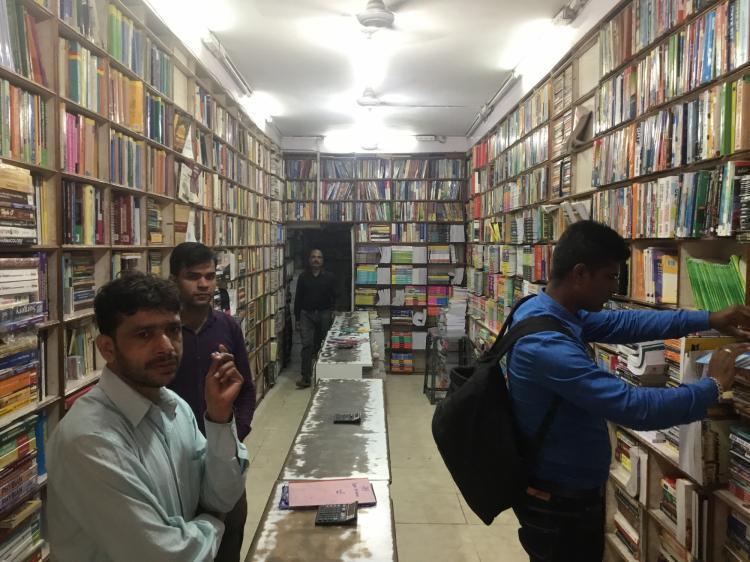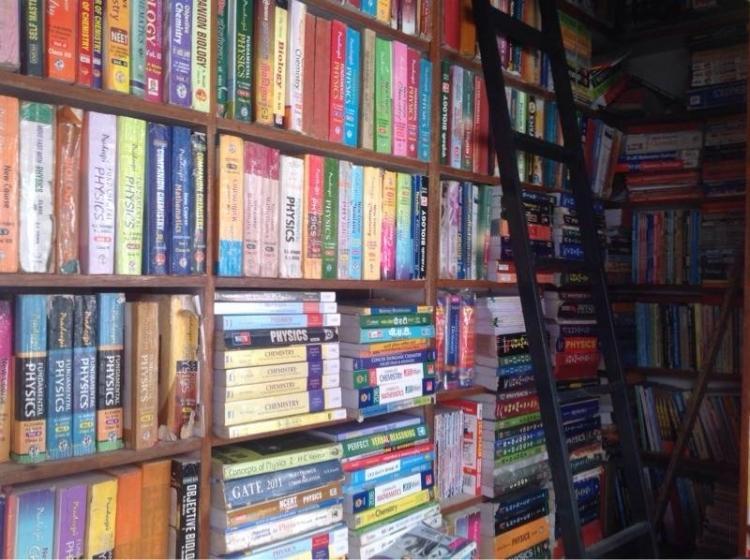The first image is the image on the left, the second image is the image on the right. Considering the images on both sides, is "There are people standing." valid? Answer yes or no. Yes. The first image is the image on the left, the second image is the image on the right. Given the left and right images, does the statement "There are three men with black hair and brown skin inside a bookstore." hold true? Answer yes or no. Yes. 